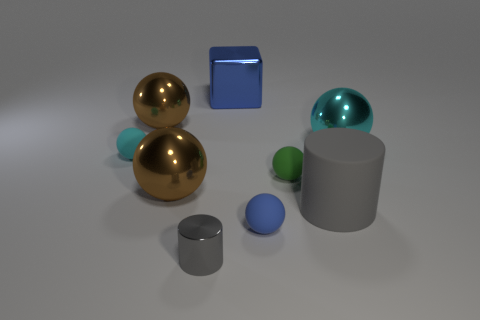Subtract 3 spheres. How many spheres are left? 3 Subtract all blue balls. How many balls are left? 5 Subtract all green rubber spheres. How many spheres are left? 5 Subtract all brown spheres. Subtract all purple cubes. How many spheres are left? 4 Add 1 large cubes. How many objects exist? 10 Subtract all cylinders. How many objects are left? 7 Subtract 0 red spheres. How many objects are left? 9 Subtract all small cyan things. Subtract all cyan metallic objects. How many objects are left? 7 Add 3 large blue metal objects. How many large blue metal objects are left? 4 Add 2 big shiny things. How many big shiny things exist? 6 